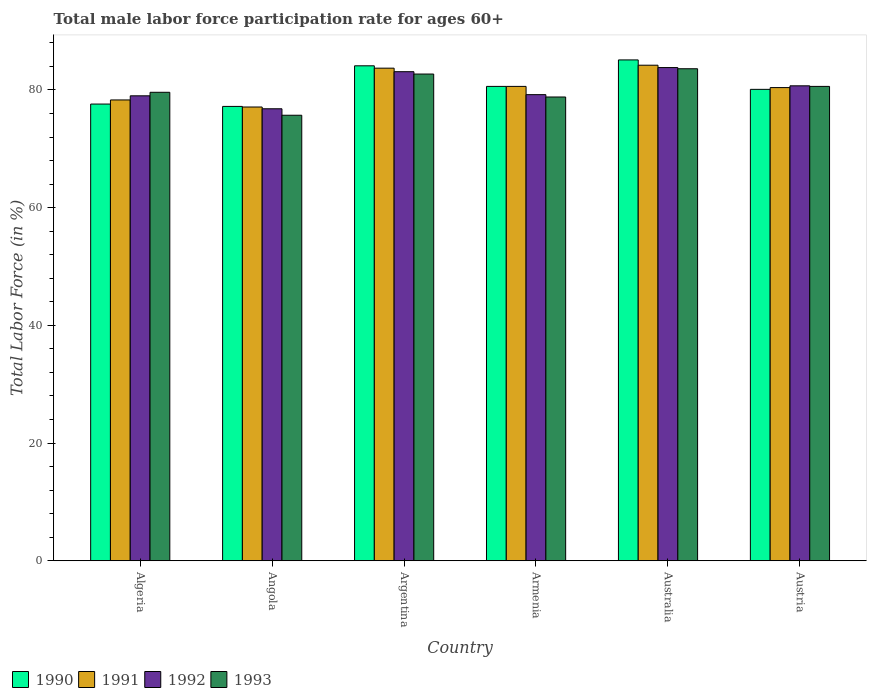How many different coloured bars are there?
Your response must be concise. 4. How many groups of bars are there?
Offer a terse response. 6. How many bars are there on the 1st tick from the left?
Ensure brevity in your answer.  4. How many bars are there on the 4th tick from the right?
Keep it short and to the point. 4. What is the label of the 3rd group of bars from the left?
Provide a short and direct response. Argentina. In how many cases, is the number of bars for a given country not equal to the number of legend labels?
Provide a succinct answer. 0. What is the male labor force participation rate in 1993 in Armenia?
Offer a terse response. 78.8. Across all countries, what is the maximum male labor force participation rate in 1993?
Ensure brevity in your answer.  83.6. Across all countries, what is the minimum male labor force participation rate in 1990?
Provide a succinct answer. 77.2. In which country was the male labor force participation rate in 1990 maximum?
Provide a succinct answer. Australia. In which country was the male labor force participation rate in 1992 minimum?
Provide a short and direct response. Angola. What is the total male labor force participation rate in 1993 in the graph?
Your answer should be compact. 481. What is the difference between the male labor force participation rate in 1992 in Austria and the male labor force participation rate in 1991 in Algeria?
Provide a short and direct response. 2.4. What is the average male labor force participation rate in 1993 per country?
Your answer should be very brief. 80.17. What is the difference between the male labor force participation rate of/in 1990 and male labor force participation rate of/in 1991 in Australia?
Your answer should be compact. 0.9. In how many countries, is the male labor force participation rate in 1993 greater than 48 %?
Offer a very short reply. 6. What is the ratio of the male labor force participation rate in 1993 in Algeria to that in Austria?
Your answer should be very brief. 0.99. Is the difference between the male labor force participation rate in 1990 in Angola and Australia greater than the difference between the male labor force participation rate in 1991 in Angola and Australia?
Provide a succinct answer. No. What is the difference between the highest and the second highest male labor force participation rate in 1991?
Keep it short and to the point. -3.1. What is the difference between the highest and the lowest male labor force participation rate in 1990?
Offer a very short reply. 7.9. In how many countries, is the male labor force participation rate in 1993 greater than the average male labor force participation rate in 1993 taken over all countries?
Your response must be concise. 3. Is it the case that in every country, the sum of the male labor force participation rate in 1992 and male labor force participation rate in 1990 is greater than the sum of male labor force participation rate in 1993 and male labor force participation rate in 1991?
Give a very brief answer. No. What does the 1st bar from the left in Australia represents?
Offer a very short reply. 1990. What does the 4th bar from the right in Austria represents?
Provide a succinct answer. 1990. How many bars are there?
Make the answer very short. 24. What is the difference between two consecutive major ticks on the Y-axis?
Offer a very short reply. 20. Are the values on the major ticks of Y-axis written in scientific E-notation?
Provide a short and direct response. No. Does the graph contain grids?
Ensure brevity in your answer.  No. Where does the legend appear in the graph?
Your answer should be compact. Bottom left. What is the title of the graph?
Offer a very short reply. Total male labor force participation rate for ages 60+. Does "2014" appear as one of the legend labels in the graph?
Offer a terse response. No. What is the label or title of the X-axis?
Provide a short and direct response. Country. What is the label or title of the Y-axis?
Your response must be concise. Total Labor Force (in %). What is the Total Labor Force (in %) in 1990 in Algeria?
Provide a succinct answer. 77.6. What is the Total Labor Force (in %) in 1991 in Algeria?
Provide a short and direct response. 78.3. What is the Total Labor Force (in %) in 1992 in Algeria?
Offer a terse response. 79. What is the Total Labor Force (in %) in 1993 in Algeria?
Your answer should be compact. 79.6. What is the Total Labor Force (in %) in 1990 in Angola?
Ensure brevity in your answer.  77.2. What is the Total Labor Force (in %) of 1991 in Angola?
Your answer should be compact. 77.1. What is the Total Labor Force (in %) in 1992 in Angola?
Your answer should be very brief. 76.8. What is the Total Labor Force (in %) in 1993 in Angola?
Your response must be concise. 75.7. What is the Total Labor Force (in %) in 1990 in Argentina?
Give a very brief answer. 84.1. What is the Total Labor Force (in %) in 1991 in Argentina?
Provide a short and direct response. 83.7. What is the Total Labor Force (in %) of 1992 in Argentina?
Offer a terse response. 83.1. What is the Total Labor Force (in %) of 1993 in Argentina?
Offer a very short reply. 82.7. What is the Total Labor Force (in %) in 1990 in Armenia?
Your response must be concise. 80.6. What is the Total Labor Force (in %) of 1991 in Armenia?
Provide a succinct answer. 80.6. What is the Total Labor Force (in %) in 1992 in Armenia?
Provide a succinct answer. 79.2. What is the Total Labor Force (in %) of 1993 in Armenia?
Make the answer very short. 78.8. What is the Total Labor Force (in %) of 1990 in Australia?
Provide a short and direct response. 85.1. What is the Total Labor Force (in %) of 1991 in Australia?
Provide a succinct answer. 84.2. What is the Total Labor Force (in %) in 1992 in Australia?
Your response must be concise. 83.8. What is the Total Labor Force (in %) in 1993 in Australia?
Your answer should be very brief. 83.6. What is the Total Labor Force (in %) of 1990 in Austria?
Give a very brief answer. 80.1. What is the Total Labor Force (in %) of 1991 in Austria?
Provide a short and direct response. 80.4. What is the Total Labor Force (in %) of 1992 in Austria?
Provide a short and direct response. 80.7. What is the Total Labor Force (in %) in 1993 in Austria?
Make the answer very short. 80.6. Across all countries, what is the maximum Total Labor Force (in %) in 1990?
Make the answer very short. 85.1. Across all countries, what is the maximum Total Labor Force (in %) of 1991?
Your answer should be very brief. 84.2. Across all countries, what is the maximum Total Labor Force (in %) in 1992?
Your response must be concise. 83.8. Across all countries, what is the maximum Total Labor Force (in %) of 1993?
Offer a very short reply. 83.6. Across all countries, what is the minimum Total Labor Force (in %) in 1990?
Your answer should be compact. 77.2. Across all countries, what is the minimum Total Labor Force (in %) of 1991?
Make the answer very short. 77.1. Across all countries, what is the minimum Total Labor Force (in %) of 1992?
Make the answer very short. 76.8. Across all countries, what is the minimum Total Labor Force (in %) of 1993?
Provide a succinct answer. 75.7. What is the total Total Labor Force (in %) in 1990 in the graph?
Keep it short and to the point. 484.7. What is the total Total Labor Force (in %) in 1991 in the graph?
Provide a succinct answer. 484.3. What is the total Total Labor Force (in %) of 1992 in the graph?
Ensure brevity in your answer.  482.6. What is the total Total Labor Force (in %) of 1993 in the graph?
Ensure brevity in your answer.  481. What is the difference between the Total Labor Force (in %) of 1990 in Algeria and that in Angola?
Your answer should be compact. 0.4. What is the difference between the Total Labor Force (in %) in 1990 in Algeria and that in Argentina?
Offer a terse response. -6.5. What is the difference between the Total Labor Force (in %) of 1991 in Algeria and that in Argentina?
Your answer should be compact. -5.4. What is the difference between the Total Labor Force (in %) of 1992 in Algeria and that in Argentina?
Keep it short and to the point. -4.1. What is the difference between the Total Labor Force (in %) of 1990 in Algeria and that in Australia?
Your response must be concise. -7.5. What is the difference between the Total Labor Force (in %) of 1993 in Algeria and that in Australia?
Ensure brevity in your answer.  -4. What is the difference between the Total Labor Force (in %) of 1991 in Algeria and that in Austria?
Make the answer very short. -2.1. What is the difference between the Total Labor Force (in %) in 1992 in Algeria and that in Austria?
Your answer should be very brief. -1.7. What is the difference between the Total Labor Force (in %) in 1993 in Algeria and that in Austria?
Give a very brief answer. -1. What is the difference between the Total Labor Force (in %) of 1990 in Angola and that in Argentina?
Your response must be concise. -6.9. What is the difference between the Total Labor Force (in %) of 1991 in Angola and that in Argentina?
Provide a short and direct response. -6.6. What is the difference between the Total Labor Force (in %) of 1992 in Angola and that in Argentina?
Make the answer very short. -6.3. What is the difference between the Total Labor Force (in %) in 1993 in Angola and that in Argentina?
Your answer should be compact. -7. What is the difference between the Total Labor Force (in %) in 1990 in Angola and that in Armenia?
Make the answer very short. -3.4. What is the difference between the Total Labor Force (in %) of 1992 in Angola and that in Armenia?
Your response must be concise. -2.4. What is the difference between the Total Labor Force (in %) in 1993 in Angola and that in Armenia?
Provide a short and direct response. -3.1. What is the difference between the Total Labor Force (in %) of 1993 in Angola and that in Australia?
Your answer should be compact. -7.9. What is the difference between the Total Labor Force (in %) of 1991 in Argentina and that in Armenia?
Give a very brief answer. 3.1. What is the difference between the Total Labor Force (in %) of 1992 in Argentina and that in Armenia?
Provide a succinct answer. 3.9. What is the difference between the Total Labor Force (in %) of 1991 in Argentina and that in Australia?
Ensure brevity in your answer.  -0.5. What is the difference between the Total Labor Force (in %) of 1993 in Argentina and that in Austria?
Your answer should be compact. 2.1. What is the difference between the Total Labor Force (in %) in 1993 in Armenia and that in Austria?
Provide a succinct answer. -1.8. What is the difference between the Total Labor Force (in %) in 1991 in Australia and that in Austria?
Your answer should be compact. 3.8. What is the difference between the Total Labor Force (in %) of 1992 in Australia and that in Austria?
Ensure brevity in your answer.  3.1. What is the difference between the Total Labor Force (in %) of 1993 in Australia and that in Austria?
Offer a very short reply. 3. What is the difference between the Total Labor Force (in %) in 1990 in Algeria and the Total Labor Force (in %) in 1991 in Angola?
Provide a short and direct response. 0.5. What is the difference between the Total Labor Force (in %) of 1991 in Algeria and the Total Labor Force (in %) of 1992 in Angola?
Give a very brief answer. 1.5. What is the difference between the Total Labor Force (in %) in 1991 in Algeria and the Total Labor Force (in %) in 1993 in Angola?
Your answer should be compact. 2.6. What is the difference between the Total Labor Force (in %) in 1990 in Algeria and the Total Labor Force (in %) in 1991 in Argentina?
Offer a terse response. -6.1. What is the difference between the Total Labor Force (in %) in 1990 in Algeria and the Total Labor Force (in %) in 1992 in Argentina?
Provide a succinct answer. -5.5. What is the difference between the Total Labor Force (in %) in 1990 in Algeria and the Total Labor Force (in %) in 1993 in Argentina?
Give a very brief answer. -5.1. What is the difference between the Total Labor Force (in %) in 1991 in Algeria and the Total Labor Force (in %) in 1992 in Argentina?
Offer a very short reply. -4.8. What is the difference between the Total Labor Force (in %) in 1990 in Algeria and the Total Labor Force (in %) in 1991 in Armenia?
Provide a short and direct response. -3. What is the difference between the Total Labor Force (in %) of 1991 in Algeria and the Total Labor Force (in %) of 1992 in Armenia?
Your answer should be very brief. -0.9. What is the difference between the Total Labor Force (in %) in 1991 in Algeria and the Total Labor Force (in %) in 1993 in Armenia?
Your answer should be compact. -0.5. What is the difference between the Total Labor Force (in %) in 1992 in Algeria and the Total Labor Force (in %) in 1993 in Armenia?
Your answer should be compact. 0.2. What is the difference between the Total Labor Force (in %) of 1990 in Algeria and the Total Labor Force (in %) of 1991 in Australia?
Your answer should be compact. -6.6. What is the difference between the Total Labor Force (in %) in 1990 in Algeria and the Total Labor Force (in %) in 1991 in Austria?
Your answer should be very brief. -2.8. What is the difference between the Total Labor Force (in %) of 1991 in Algeria and the Total Labor Force (in %) of 1992 in Austria?
Offer a terse response. -2.4. What is the difference between the Total Labor Force (in %) in 1991 in Algeria and the Total Labor Force (in %) in 1993 in Austria?
Offer a terse response. -2.3. What is the difference between the Total Labor Force (in %) in 1990 in Angola and the Total Labor Force (in %) in 1991 in Argentina?
Provide a short and direct response. -6.5. What is the difference between the Total Labor Force (in %) of 1990 in Angola and the Total Labor Force (in %) of 1992 in Argentina?
Make the answer very short. -5.9. What is the difference between the Total Labor Force (in %) in 1990 in Angola and the Total Labor Force (in %) in 1993 in Argentina?
Offer a very short reply. -5.5. What is the difference between the Total Labor Force (in %) in 1991 in Angola and the Total Labor Force (in %) in 1992 in Argentina?
Offer a very short reply. -6. What is the difference between the Total Labor Force (in %) of 1991 in Angola and the Total Labor Force (in %) of 1993 in Argentina?
Make the answer very short. -5.6. What is the difference between the Total Labor Force (in %) of 1992 in Angola and the Total Labor Force (in %) of 1993 in Argentina?
Make the answer very short. -5.9. What is the difference between the Total Labor Force (in %) in 1990 in Angola and the Total Labor Force (in %) in 1992 in Armenia?
Offer a very short reply. -2. What is the difference between the Total Labor Force (in %) of 1990 in Angola and the Total Labor Force (in %) of 1993 in Armenia?
Keep it short and to the point. -1.6. What is the difference between the Total Labor Force (in %) of 1990 in Angola and the Total Labor Force (in %) of 1991 in Australia?
Keep it short and to the point. -7. What is the difference between the Total Labor Force (in %) in 1990 in Angola and the Total Labor Force (in %) in 1993 in Australia?
Provide a succinct answer. -6.4. What is the difference between the Total Labor Force (in %) of 1991 in Angola and the Total Labor Force (in %) of 1992 in Australia?
Give a very brief answer. -6.7. What is the difference between the Total Labor Force (in %) of 1991 in Angola and the Total Labor Force (in %) of 1993 in Australia?
Your response must be concise. -6.5. What is the difference between the Total Labor Force (in %) in 1992 in Angola and the Total Labor Force (in %) in 1993 in Australia?
Provide a succinct answer. -6.8. What is the difference between the Total Labor Force (in %) of 1990 in Angola and the Total Labor Force (in %) of 1992 in Austria?
Make the answer very short. -3.5. What is the difference between the Total Labor Force (in %) of 1991 in Angola and the Total Labor Force (in %) of 1992 in Austria?
Ensure brevity in your answer.  -3.6. What is the difference between the Total Labor Force (in %) of 1992 in Angola and the Total Labor Force (in %) of 1993 in Austria?
Your response must be concise. -3.8. What is the difference between the Total Labor Force (in %) in 1990 in Argentina and the Total Labor Force (in %) in 1991 in Armenia?
Your response must be concise. 3.5. What is the difference between the Total Labor Force (in %) in 1990 in Argentina and the Total Labor Force (in %) in 1993 in Armenia?
Keep it short and to the point. 5.3. What is the difference between the Total Labor Force (in %) of 1991 in Argentina and the Total Labor Force (in %) of 1992 in Armenia?
Ensure brevity in your answer.  4.5. What is the difference between the Total Labor Force (in %) in 1992 in Argentina and the Total Labor Force (in %) in 1993 in Armenia?
Make the answer very short. 4.3. What is the difference between the Total Labor Force (in %) of 1990 in Argentina and the Total Labor Force (in %) of 1991 in Australia?
Provide a short and direct response. -0.1. What is the difference between the Total Labor Force (in %) in 1990 in Argentina and the Total Labor Force (in %) in 1992 in Australia?
Your answer should be very brief. 0.3. What is the difference between the Total Labor Force (in %) in 1992 in Argentina and the Total Labor Force (in %) in 1993 in Australia?
Provide a short and direct response. -0.5. What is the difference between the Total Labor Force (in %) of 1990 in Argentina and the Total Labor Force (in %) of 1992 in Austria?
Offer a terse response. 3.4. What is the difference between the Total Labor Force (in %) in 1990 in Argentina and the Total Labor Force (in %) in 1993 in Austria?
Provide a succinct answer. 3.5. What is the difference between the Total Labor Force (in %) of 1991 in Argentina and the Total Labor Force (in %) of 1993 in Austria?
Your response must be concise. 3.1. What is the difference between the Total Labor Force (in %) in 1990 in Armenia and the Total Labor Force (in %) in 1992 in Australia?
Keep it short and to the point. -3.2. What is the difference between the Total Labor Force (in %) in 1990 in Armenia and the Total Labor Force (in %) in 1993 in Australia?
Your answer should be compact. -3. What is the difference between the Total Labor Force (in %) of 1991 in Armenia and the Total Labor Force (in %) of 1992 in Australia?
Ensure brevity in your answer.  -3.2. What is the difference between the Total Labor Force (in %) of 1991 in Armenia and the Total Labor Force (in %) of 1993 in Australia?
Provide a short and direct response. -3. What is the difference between the Total Labor Force (in %) of 1992 in Armenia and the Total Labor Force (in %) of 1993 in Australia?
Ensure brevity in your answer.  -4.4. What is the difference between the Total Labor Force (in %) in 1990 in Armenia and the Total Labor Force (in %) in 1991 in Austria?
Keep it short and to the point. 0.2. What is the difference between the Total Labor Force (in %) in 1991 in Armenia and the Total Labor Force (in %) in 1993 in Austria?
Offer a terse response. 0. What is the difference between the Total Labor Force (in %) of 1992 in Armenia and the Total Labor Force (in %) of 1993 in Austria?
Provide a succinct answer. -1.4. What is the difference between the Total Labor Force (in %) of 1990 in Australia and the Total Labor Force (in %) of 1991 in Austria?
Give a very brief answer. 4.7. What is the difference between the Total Labor Force (in %) of 1990 in Australia and the Total Labor Force (in %) of 1992 in Austria?
Offer a terse response. 4.4. What is the difference between the Total Labor Force (in %) of 1991 in Australia and the Total Labor Force (in %) of 1992 in Austria?
Your answer should be compact. 3.5. What is the difference between the Total Labor Force (in %) in 1992 in Australia and the Total Labor Force (in %) in 1993 in Austria?
Keep it short and to the point. 3.2. What is the average Total Labor Force (in %) in 1990 per country?
Your answer should be very brief. 80.78. What is the average Total Labor Force (in %) of 1991 per country?
Keep it short and to the point. 80.72. What is the average Total Labor Force (in %) in 1992 per country?
Provide a succinct answer. 80.43. What is the average Total Labor Force (in %) in 1993 per country?
Give a very brief answer. 80.17. What is the difference between the Total Labor Force (in %) of 1990 and Total Labor Force (in %) of 1992 in Algeria?
Provide a succinct answer. -1.4. What is the difference between the Total Labor Force (in %) in 1990 and Total Labor Force (in %) in 1993 in Algeria?
Your response must be concise. -2. What is the difference between the Total Labor Force (in %) in 1992 and Total Labor Force (in %) in 1993 in Algeria?
Your answer should be very brief. -0.6. What is the difference between the Total Labor Force (in %) in 1991 and Total Labor Force (in %) in 1993 in Angola?
Offer a terse response. 1.4. What is the difference between the Total Labor Force (in %) in 1992 and Total Labor Force (in %) in 1993 in Angola?
Give a very brief answer. 1.1. What is the difference between the Total Labor Force (in %) of 1990 and Total Labor Force (in %) of 1993 in Argentina?
Make the answer very short. 1.4. What is the difference between the Total Labor Force (in %) of 1992 and Total Labor Force (in %) of 1993 in Argentina?
Your response must be concise. 0.4. What is the difference between the Total Labor Force (in %) in 1990 and Total Labor Force (in %) in 1992 in Armenia?
Your answer should be very brief. 1.4. What is the difference between the Total Labor Force (in %) in 1990 and Total Labor Force (in %) in 1993 in Armenia?
Your response must be concise. 1.8. What is the difference between the Total Labor Force (in %) in 1991 and Total Labor Force (in %) in 1992 in Armenia?
Make the answer very short. 1.4. What is the difference between the Total Labor Force (in %) of 1992 and Total Labor Force (in %) of 1993 in Armenia?
Your answer should be very brief. 0.4. What is the difference between the Total Labor Force (in %) of 1990 and Total Labor Force (in %) of 1993 in Australia?
Provide a succinct answer. 1.5. What is the difference between the Total Labor Force (in %) of 1992 and Total Labor Force (in %) of 1993 in Australia?
Offer a very short reply. 0.2. What is the difference between the Total Labor Force (in %) of 1990 and Total Labor Force (in %) of 1991 in Austria?
Offer a terse response. -0.3. What is the difference between the Total Labor Force (in %) in 1990 and Total Labor Force (in %) in 1993 in Austria?
Keep it short and to the point. -0.5. What is the difference between the Total Labor Force (in %) of 1991 and Total Labor Force (in %) of 1992 in Austria?
Give a very brief answer. -0.3. What is the difference between the Total Labor Force (in %) of 1992 and Total Labor Force (in %) of 1993 in Austria?
Your answer should be very brief. 0.1. What is the ratio of the Total Labor Force (in %) in 1991 in Algeria to that in Angola?
Your response must be concise. 1.02. What is the ratio of the Total Labor Force (in %) in 1992 in Algeria to that in Angola?
Offer a very short reply. 1.03. What is the ratio of the Total Labor Force (in %) in 1993 in Algeria to that in Angola?
Your answer should be very brief. 1.05. What is the ratio of the Total Labor Force (in %) of 1990 in Algeria to that in Argentina?
Offer a very short reply. 0.92. What is the ratio of the Total Labor Force (in %) of 1991 in Algeria to that in Argentina?
Your answer should be very brief. 0.94. What is the ratio of the Total Labor Force (in %) of 1992 in Algeria to that in Argentina?
Your answer should be compact. 0.95. What is the ratio of the Total Labor Force (in %) of 1993 in Algeria to that in Argentina?
Your answer should be compact. 0.96. What is the ratio of the Total Labor Force (in %) of 1990 in Algeria to that in Armenia?
Make the answer very short. 0.96. What is the ratio of the Total Labor Force (in %) of 1991 in Algeria to that in Armenia?
Your response must be concise. 0.97. What is the ratio of the Total Labor Force (in %) in 1993 in Algeria to that in Armenia?
Your answer should be very brief. 1.01. What is the ratio of the Total Labor Force (in %) of 1990 in Algeria to that in Australia?
Make the answer very short. 0.91. What is the ratio of the Total Labor Force (in %) of 1991 in Algeria to that in Australia?
Your answer should be compact. 0.93. What is the ratio of the Total Labor Force (in %) of 1992 in Algeria to that in Australia?
Your answer should be very brief. 0.94. What is the ratio of the Total Labor Force (in %) of 1993 in Algeria to that in Australia?
Offer a very short reply. 0.95. What is the ratio of the Total Labor Force (in %) of 1990 in Algeria to that in Austria?
Provide a short and direct response. 0.97. What is the ratio of the Total Labor Force (in %) of 1991 in Algeria to that in Austria?
Make the answer very short. 0.97. What is the ratio of the Total Labor Force (in %) in 1992 in Algeria to that in Austria?
Make the answer very short. 0.98. What is the ratio of the Total Labor Force (in %) of 1993 in Algeria to that in Austria?
Offer a terse response. 0.99. What is the ratio of the Total Labor Force (in %) in 1990 in Angola to that in Argentina?
Make the answer very short. 0.92. What is the ratio of the Total Labor Force (in %) of 1991 in Angola to that in Argentina?
Ensure brevity in your answer.  0.92. What is the ratio of the Total Labor Force (in %) of 1992 in Angola to that in Argentina?
Keep it short and to the point. 0.92. What is the ratio of the Total Labor Force (in %) in 1993 in Angola to that in Argentina?
Make the answer very short. 0.92. What is the ratio of the Total Labor Force (in %) of 1990 in Angola to that in Armenia?
Offer a very short reply. 0.96. What is the ratio of the Total Labor Force (in %) in 1991 in Angola to that in Armenia?
Give a very brief answer. 0.96. What is the ratio of the Total Labor Force (in %) in 1992 in Angola to that in Armenia?
Provide a succinct answer. 0.97. What is the ratio of the Total Labor Force (in %) of 1993 in Angola to that in Armenia?
Keep it short and to the point. 0.96. What is the ratio of the Total Labor Force (in %) in 1990 in Angola to that in Australia?
Ensure brevity in your answer.  0.91. What is the ratio of the Total Labor Force (in %) of 1991 in Angola to that in Australia?
Your answer should be very brief. 0.92. What is the ratio of the Total Labor Force (in %) of 1992 in Angola to that in Australia?
Keep it short and to the point. 0.92. What is the ratio of the Total Labor Force (in %) in 1993 in Angola to that in Australia?
Your answer should be very brief. 0.91. What is the ratio of the Total Labor Force (in %) in 1990 in Angola to that in Austria?
Offer a terse response. 0.96. What is the ratio of the Total Labor Force (in %) of 1992 in Angola to that in Austria?
Offer a very short reply. 0.95. What is the ratio of the Total Labor Force (in %) in 1993 in Angola to that in Austria?
Offer a very short reply. 0.94. What is the ratio of the Total Labor Force (in %) in 1990 in Argentina to that in Armenia?
Your response must be concise. 1.04. What is the ratio of the Total Labor Force (in %) in 1992 in Argentina to that in Armenia?
Offer a very short reply. 1.05. What is the ratio of the Total Labor Force (in %) in 1993 in Argentina to that in Armenia?
Your answer should be very brief. 1.05. What is the ratio of the Total Labor Force (in %) in 1990 in Argentina to that in Australia?
Your answer should be very brief. 0.99. What is the ratio of the Total Labor Force (in %) in 1991 in Argentina to that in Australia?
Your response must be concise. 0.99. What is the ratio of the Total Labor Force (in %) in 1992 in Argentina to that in Australia?
Provide a short and direct response. 0.99. What is the ratio of the Total Labor Force (in %) of 1993 in Argentina to that in Australia?
Provide a succinct answer. 0.99. What is the ratio of the Total Labor Force (in %) in 1990 in Argentina to that in Austria?
Offer a terse response. 1.05. What is the ratio of the Total Labor Force (in %) in 1991 in Argentina to that in Austria?
Your response must be concise. 1.04. What is the ratio of the Total Labor Force (in %) in 1992 in Argentina to that in Austria?
Your answer should be very brief. 1.03. What is the ratio of the Total Labor Force (in %) in 1993 in Argentina to that in Austria?
Give a very brief answer. 1.03. What is the ratio of the Total Labor Force (in %) of 1990 in Armenia to that in Australia?
Make the answer very short. 0.95. What is the ratio of the Total Labor Force (in %) in 1991 in Armenia to that in Australia?
Your response must be concise. 0.96. What is the ratio of the Total Labor Force (in %) in 1992 in Armenia to that in Australia?
Ensure brevity in your answer.  0.95. What is the ratio of the Total Labor Force (in %) of 1993 in Armenia to that in Australia?
Offer a very short reply. 0.94. What is the ratio of the Total Labor Force (in %) of 1992 in Armenia to that in Austria?
Make the answer very short. 0.98. What is the ratio of the Total Labor Force (in %) in 1993 in Armenia to that in Austria?
Ensure brevity in your answer.  0.98. What is the ratio of the Total Labor Force (in %) of 1990 in Australia to that in Austria?
Make the answer very short. 1.06. What is the ratio of the Total Labor Force (in %) of 1991 in Australia to that in Austria?
Provide a succinct answer. 1.05. What is the ratio of the Total Labor Force (in %) in 1992 in Australia to that in Austria?
Give a very brief answer. 1.04. What is the ratio of the Total Labor Force (in %) of 1993 in Australia to that in Austria?
Your response must be concise. 1.04. What is the difference between the highest and the second highest Total Labor Force (in %) of 1990?
Offer a terse response. 1. What is the difference between the highest and the second highest Total Labor Force (in %) of 1992?
Provide a short and direct response. 0.7. What is the difference between the highest and the lowest Total Labor Force (in %) of 1990?
Provide a short and direct response. 7.9. 